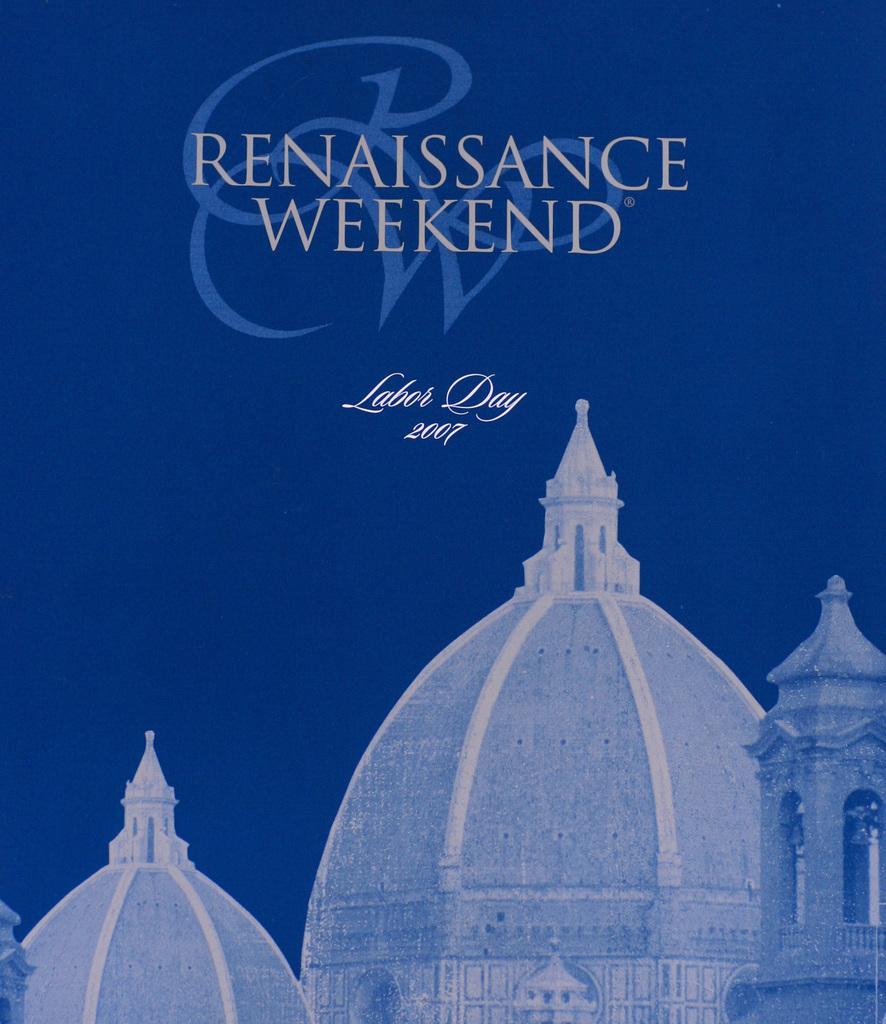What type of structures can be seen in the picture? There are domes in the picture. Where is the text located in the image? The text is in the top and middle of the picture. What color is the background of the image? The background of the image is in blue color. How many frogs are sitting on the domes in the image? There are no frogs present in the image. What expertise does the person in the image have? There is no person in the image, so it's not possible to determine their expertise. 